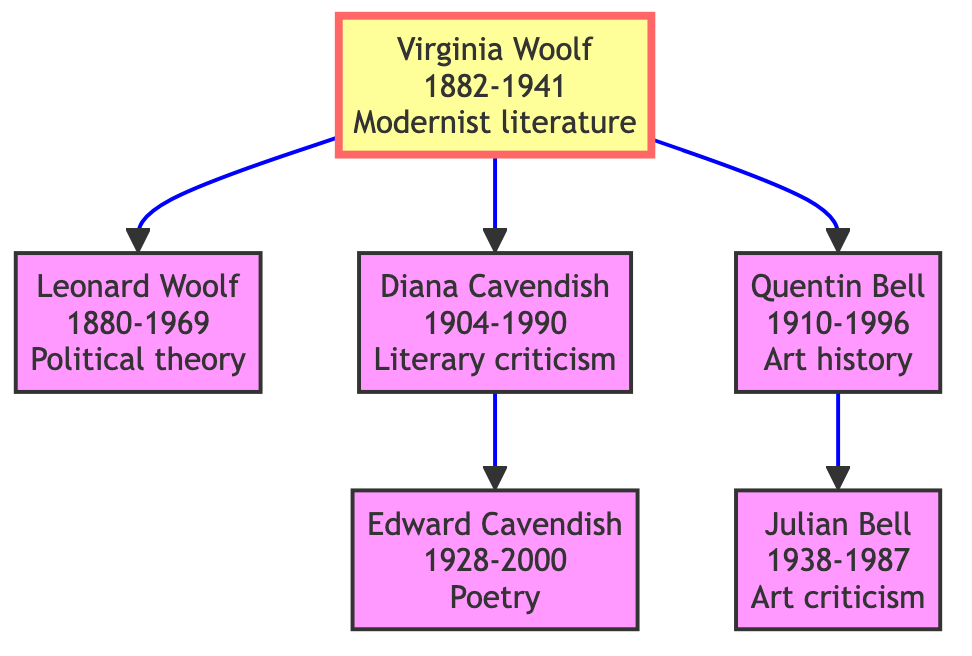What is Virginia Woolf's contribution? The diagram indicates that Virginia Woolf's contribution is "Modernist literature, stream of consciousness."
Answer: Modernist literature, stream of consciousness How many children did Virginia Woolf have? In the diagram, Virginia Woolf has three listed children: Leonard Woolf, Diana Cavendish, and Quentin Bell.
Answer: 3 Who is the child of Diana Cavendish? The diagram shows that the child of Diana Cavendish is Edward Cavendish.
Answer: Edward Cavendish What is the birth year of Leonard Woolf? From the diagram, Leonard Woolf's birth year is stated as 1880.
Answer: 1880 Which family member is known for art criticism? The diagram highlights that Julian Bell is known for "Art criticism."
Answer: Julian Bell Who are the children of Quentin Bell? The diagram indicates that Quentin Bell has one child, Julian Bell.
Answer: Julian Bell What is the relationship of Edward Cavendish to Virginia Woolf? According to the diagram, Edward Cavendish is the grandson of Virginia Woolf.
Answer: Grandson How many generations are represented in the family tree? The diagram shows that there are three generations represented: Virginia Woolf (1st generation), her children (2nd generation), and Edward Cavendish and Julian Bell (3rd generation).
Answer: 3 What literary tradition is Diana Cavendish associated with? The diagram notes that Diana Cavendish's contribution is "Literary criticism, feminist prose," highlighting her literary tradition.
Answer: Literary criticism, feminist prose 